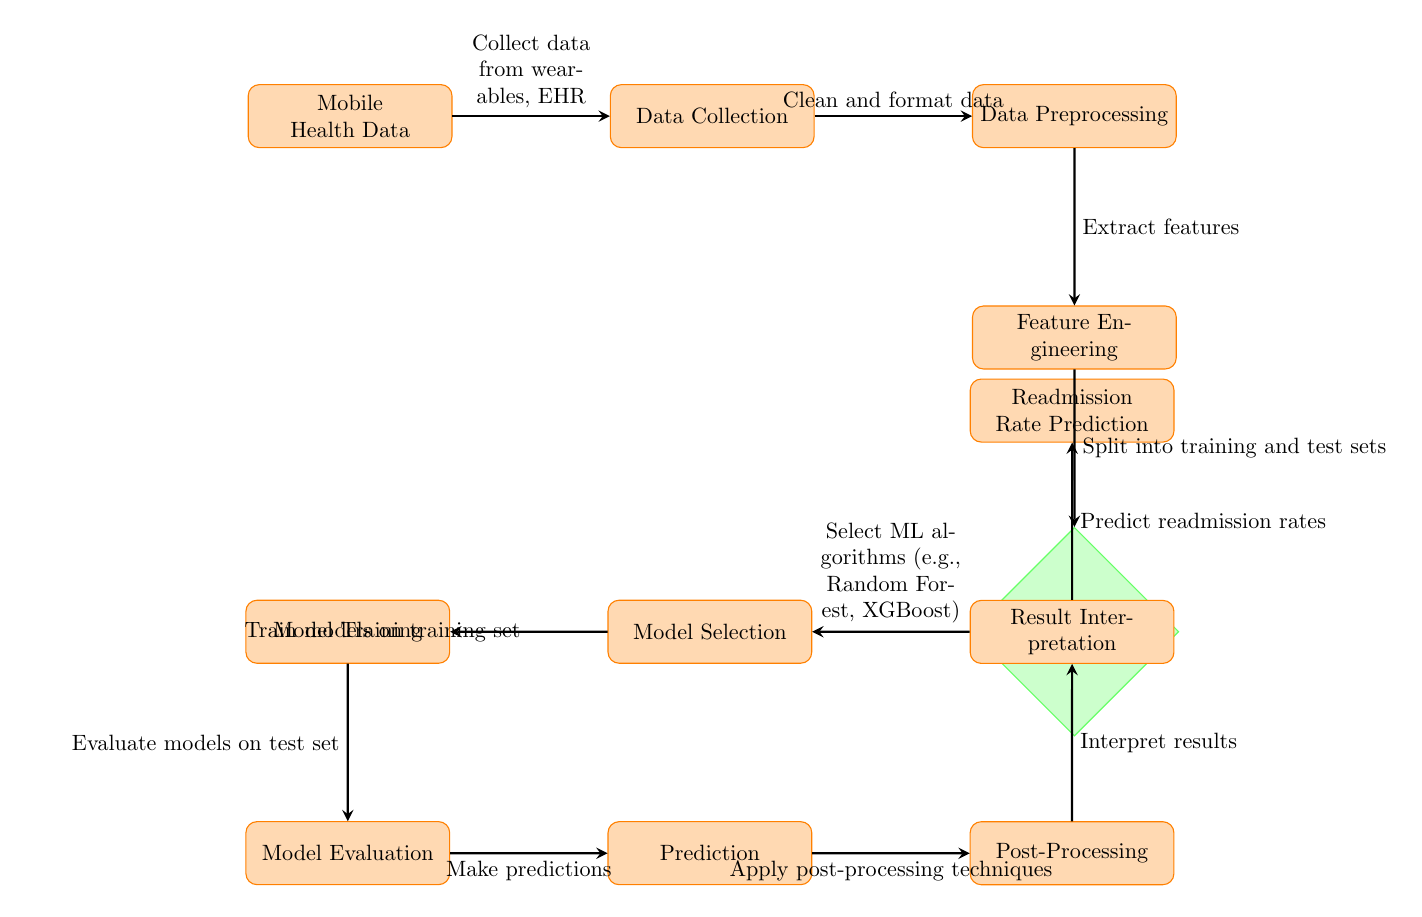What is the first node in the diagram? The first node indicated in the diagram is labeled "Mobile Health Data." It’s the starting point of the flow representing where the process begins.
Answer: Mobile Health Data How many processes are depicted in the diagram? By counting the nodes categorized as "process," we identify a total of eight processes in the diagram.
Answer: Eight What does the "Train-Test Split" node lead to? The "Train-Test Split" node leads to the "Model Selection" node. This indicates that after the data is split into training and test sets, the next step is selecting machine learning algorithms.
Answer: Model Selection What type of algorithms might be selected according to the diagram? The diagram suggests choosing among machine learning algorithms, specifically mentioning "Random Forest" and "XGBoost." These are examples provided within the "Model Selection" node.
Answer: Random Forest, XGBoost What is the final output of the diagram? The last node in the flow of the diagram is labeled "Readmission Rate Prediction," indicating that the final output of the entire process is a prediction regarding patient readmission rates.
Answer: Readmission Rate Prediction Which node involves extracting features from data? The node where feature extraction occurs is labeled "Feature Engineering." This node handles the process of transforming the preprocessed data into a meaningful set of features for model training.
Answer: Feature Engineering What happens after "Evaluate models on test set"? After the evaluation, the process moves on to the "Prediction" node, indicating that predictions are made post-evaluation of the models on the test data.
Answer: Prediction What is the relationship between "Post-Processing" and "Result Interpretation"? The "Post-Processing" node feeds into the "Result Interpretation" node, meaning that once predictions are made, they are processed further before interpreting the results.
Answer: Feed into 